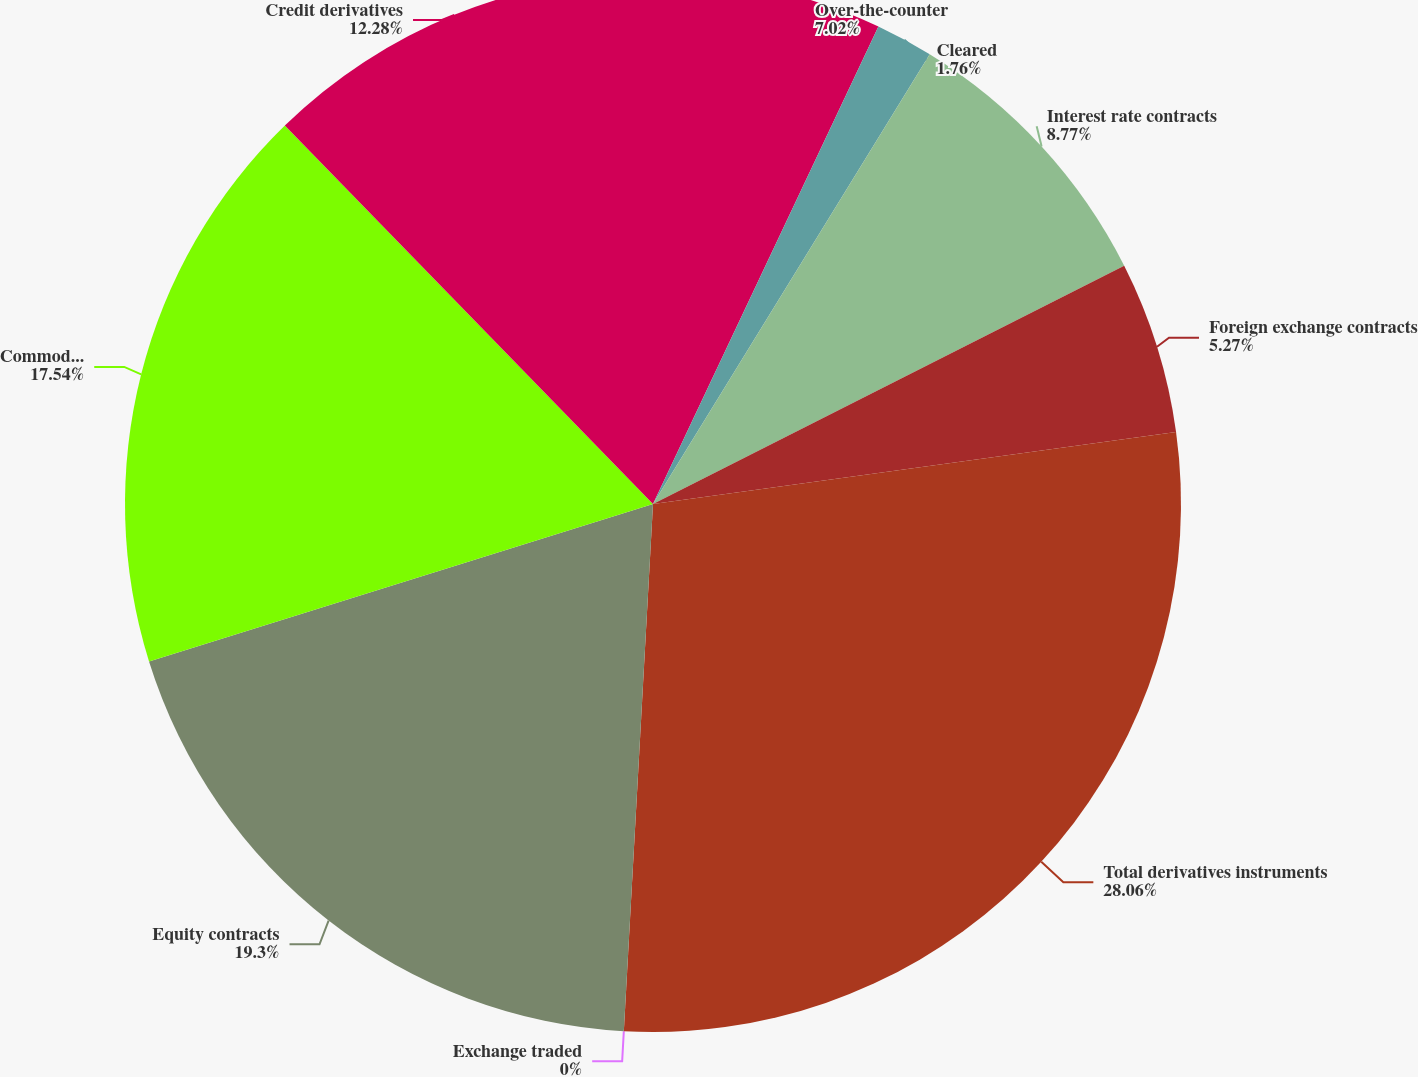Convert chart. <chart><loc_0><loc_0><loc_500><loc_500><pie_chart><fcel>Over-the-counter<fcel>Cleared<fcel>Interest rate contracts<fcel>Foreign exchange contracts<fcel>Total derivatives instruments<fcel>Exchange traded<fcel>Equity contracts<fcel>Commodity and other contracts<fcel>Credit derivatives<nl><fcel>7.02%<fcel>1.76%<fcel>8.77%<fcel>5.27%<fcel>28.06%<fcel>0.0%<fcel>19.3%<fcel>17.54%<fcel>12.28%<nl></chart> 